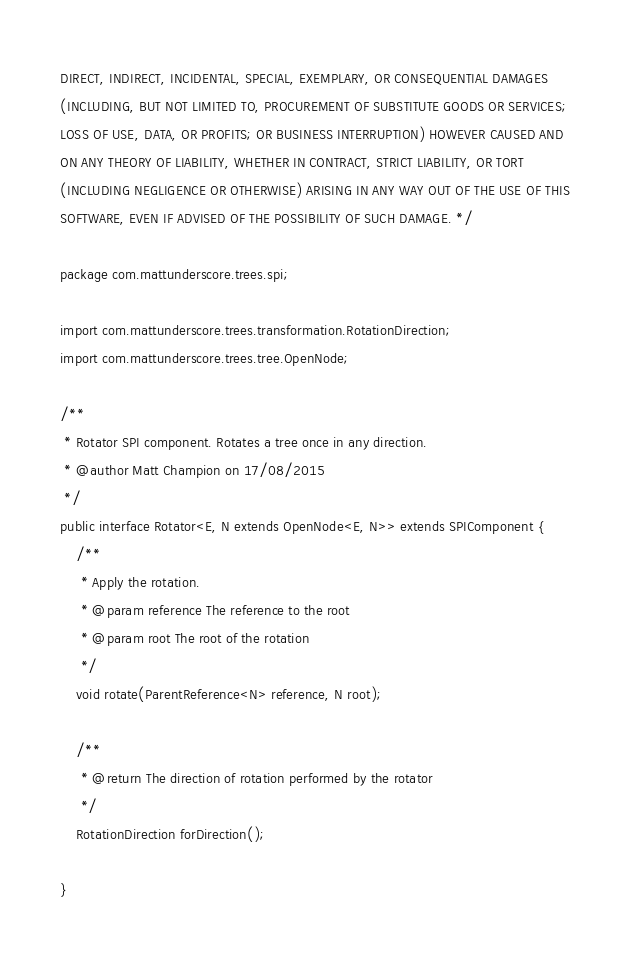<code> <loc_0><loc_0><loc_500><loc_500><_Java_>DIRECT, INDIRECT, INCIDENTAL, SPECIAL, EXEMPLARY, OR CONSEQUENTIAL DAMAGES
(INCLUDING, BUT NOT LIMITED TO, PROCUREMENT OF SUBSTITUTE GOODS OR SERVICES;
LOSS OF USE, DATA, OR PROFITS; OR BUSINESS INTERRUPTION) HOWEVER CAUSED AND
ON ANY THEORY OF LIABILITY, WHETHER IN CONTRACT, STRICT LIABILITY, OR TORT
(INCLUDING NEGLIGENCE OR OTHERWISE) ARISING IN ANY WAY OUT OF THE USE OF THIS
SOFTWARE, EVEN IF ADVISED OF THE POSSIBILITY OF SUCH DAMAGE. */

package com.mattunderscore.trees.spi;

import com.mattunderscore.trees.transformation.RotationDirection;
import com.mattunderscore.trees.tree.OpenNode;

/**
 * Rotator SPI component. Rotates a tree once in any direction.
 * @author Matt Champion on 17/08/2015
 */
public interface Rotator<E, N extends OpenNode<E, N>> extends SPIComponent {
    /**
     * Apply the rotation.
     * @param reference The reference to the root
     * @param root The root of the rotation
     */
    void rotate(ParentReference<N> reference, N root);

    /**
     * @return The direction of rotation performed by the rotator
     */
    RotationDirection forDirection();

}
</code> 